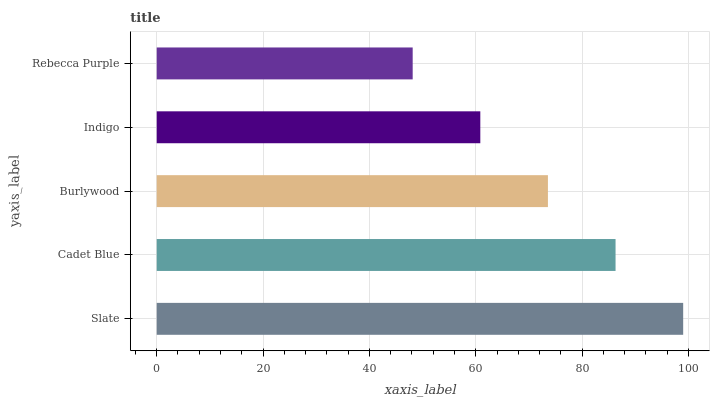Is Rebecca Purple the minimum?
Answer yes or no. Yes. Is Slate the maximum?
Answer yes or no. Yes. Is Cadet Blue the minimum?
Answer yes or no. No. Is Cadet Blue the maximum?
Answer yes or no. No. Is Slate greater than Cadet Blue?
Answer yes or no. Yes. Is Cadet Blue less than Slate?
Answer yes or no. Yes. Is Cadet Blue greater than Slate?
Answer yes or no. No. Is Slate less than Cadet Blue?
Answer yes or no. No. Is Burlywood the high median?
Answer yes or no. Yes. Is Burlywood the low median?
Answer yes or no. Yes. Is Slate the high median?
Answer yes or no. No. Is Indigo the low median?
Answer yes or no. No. 